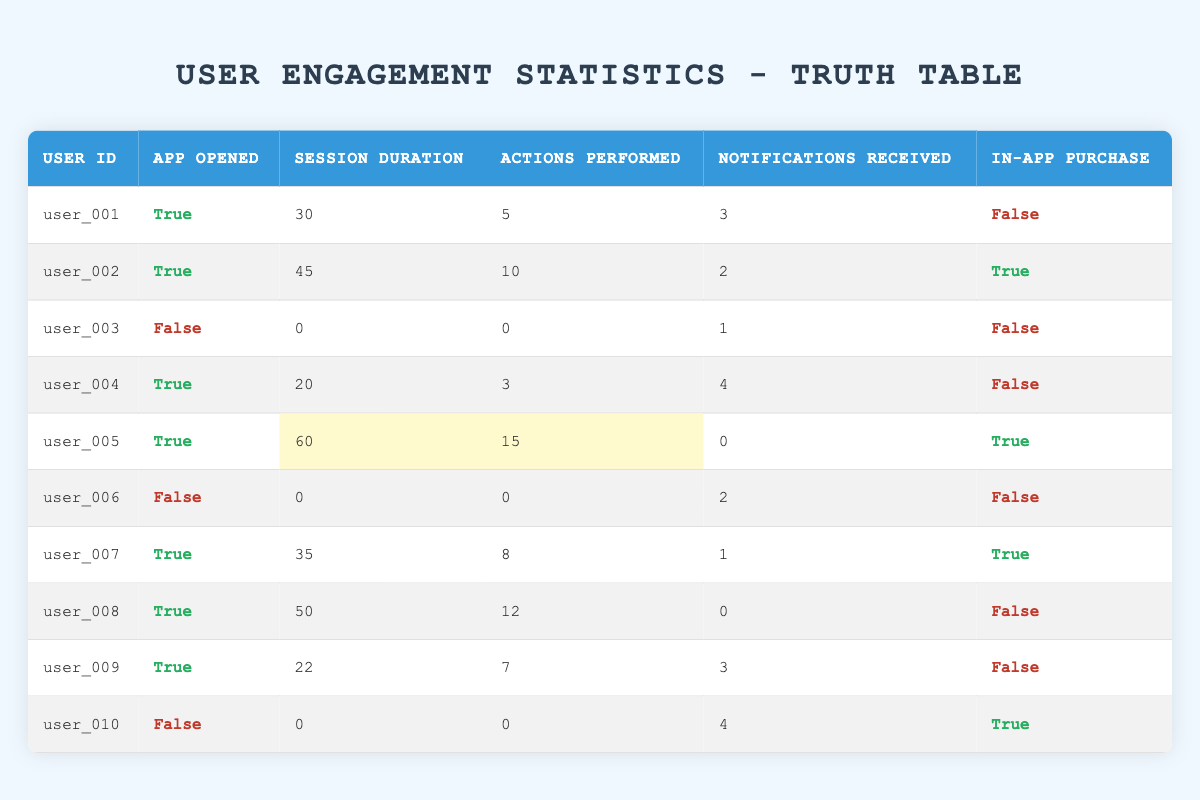What is the user ID of the user who performed the most actions? The user with the most actions performed is user_005, who did 15 actions. This can be found by reviewing the "Actions Performed" column and finding the maximum value.
Answer: user_005 How many users opened the app and made in-app purchases? By looking at the "App Opened" and "In-App Purchase" columns, we see that user_002, user_005, and user_007 opened the app and made purchases. Thus, 3 users fit this criterion.
Answer: 3 What is the total session duration of users who did not open the app? The session duration for users who did not open the app (user_003, user_006, and user_010) is 0 + 0 + 0 = 0. We add the session durations of these users.
Answer: 0 Did any user receive notifications while not opening the app? Yes, user_003 and user_010 both received 1 and 4 notifications respectively, even though they did not open the app. This is confirmed by checking the "Notifications Received" for these users while their "App Opened" status is false.
Answer: Yes What is the average session duration for users who performed more than 10 actions? Looking at users with more than 10 actions, we find user_002 (45), user_005 (60), and user_007 (35). The average is (45 + 60 + 35) / 3 = 140 / 3 = approximately 46.67.
Answer: 46.67 How many users received more than 3 notifications but did not make in-app purchases? Users who received more than 3 notifications and did not make in-app purchases are user_004 (4 notifications) and user_010 (4 notifications). Therefore, there are 2 such users.
Answer: 2 Is it true that all users who opened the app performed at least 5 actions? No, this is not true as user_004 opened the app but only performed 3 actions. We verify this by scanning the "Actions Performed" column for users whose "App Opened" status is true.
Answer: No What is the maximum number of notifications received by users who did not perform any actions? By checking users who did not perform any actions, we find user_003 (1 notification) and user_006 (2 notifications). The maximum is 2 notifications from user_006.
Answer: 2 